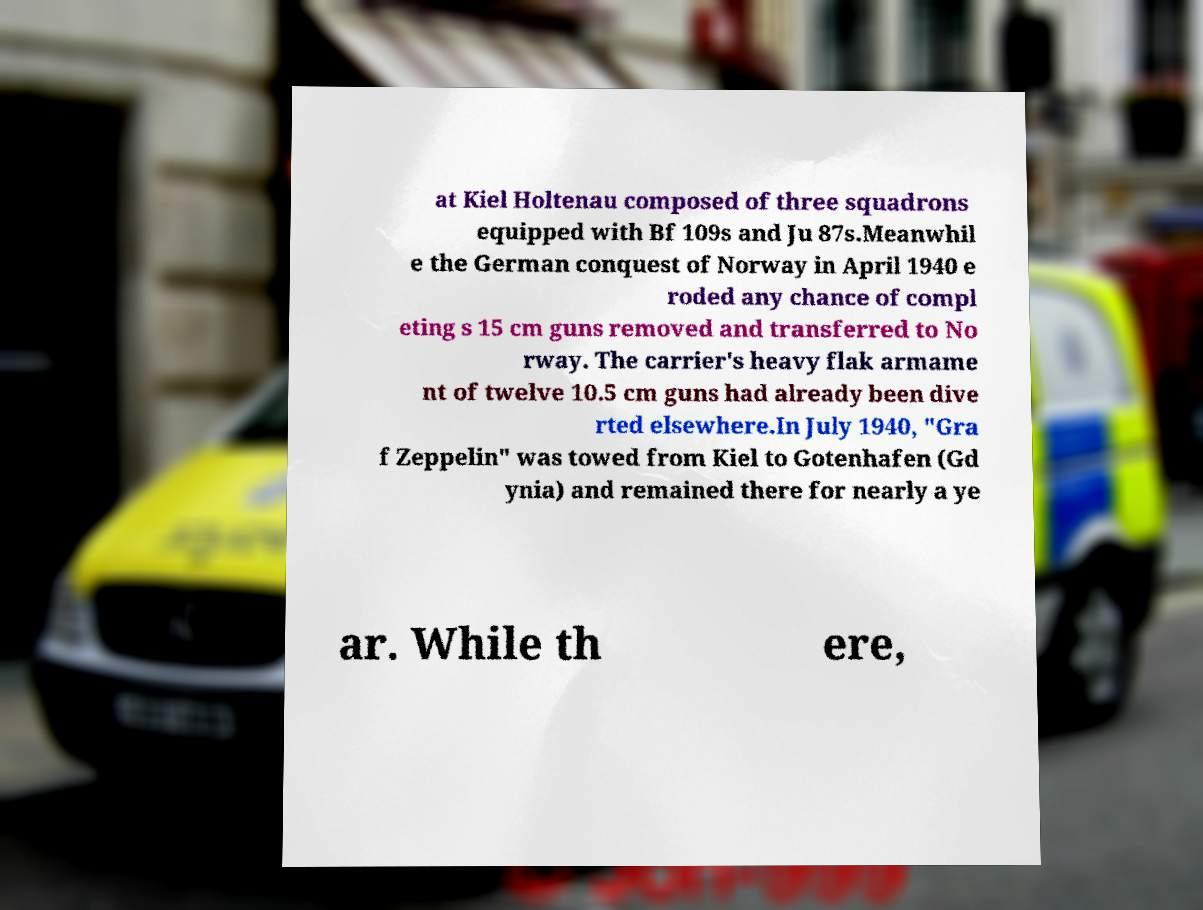What messages or text are displayed in this image? I need them in a readable, typed format. at Kiel Holtenau composed of three squadrons equipped with Bf 109s and Ju 87s.Meanwhil e the German conquest of Norway in April 1940 e roded any chance of compl eting s 15 cm guns removed and transferred to No rway. The carrier's heavy flak armame nt of twelve 10.5 cm guns had already been dive rted elsewhere.In July 1940, "Gra f Zeppelin" was towed from Kiel to Gotenhafen (Gd ynia) and remained there for nearly a ye ar. While th ere, 